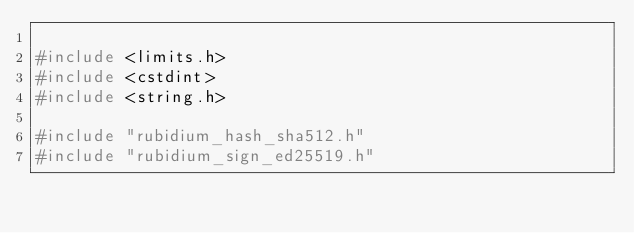<code> <loc_0><loc_0><loc_500><loc_500><_C++_>
#include <limits.h>
#include <cstdint>
#include <string.h>

#include "rubidium_hash_sha512.h"
#include "rubidium_sign_ed25519.h"</code> 